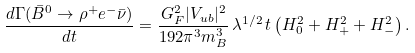<formula> <loc_0><loc_0><loc_500><loc_500>\frac { d \Gamma ( \bar { B } ^ { 0 } \to \rho ^ { + } e ^ { - } \bar { \nu } ) } { d t } = \frac { G _ { F } ^ { 2 } | V _ { u b } | ^ { 2 } } { 1 9 2 \pi ^ { 3 } m _ { B } ^ { 3 } } \, \lambda ^ { 1 / 2 } \, t \left ( H _ { 0 } ^ { 2 } + H _ { + } ^ { 2 } + H _ { - } ^ { 2 } \right ) .</formula> 